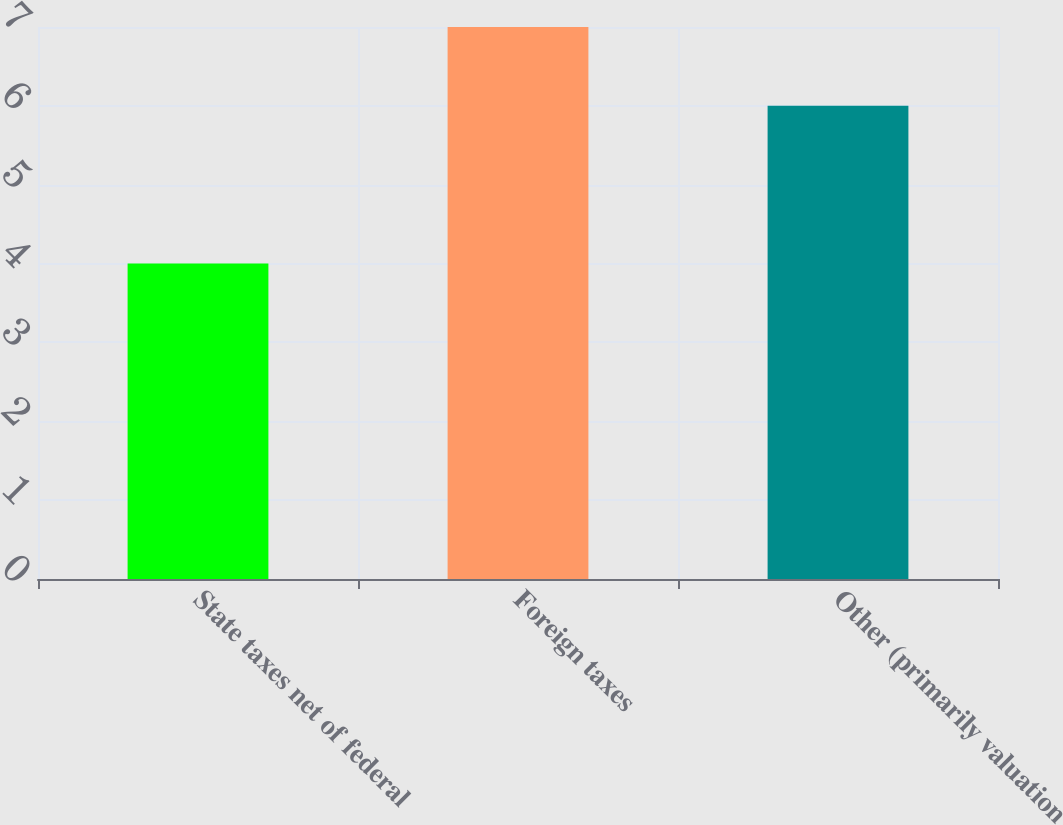Convert chart to OTSL. <chart><loc_0><loc_0><loc_500><loc_500><bar_chart><fcel>State taxes net of federal<fcel>Foreign taxes<fcel>Other (primarily valuation<nl><fcel>4<fcel>7<fcel>6<nl></chart> 